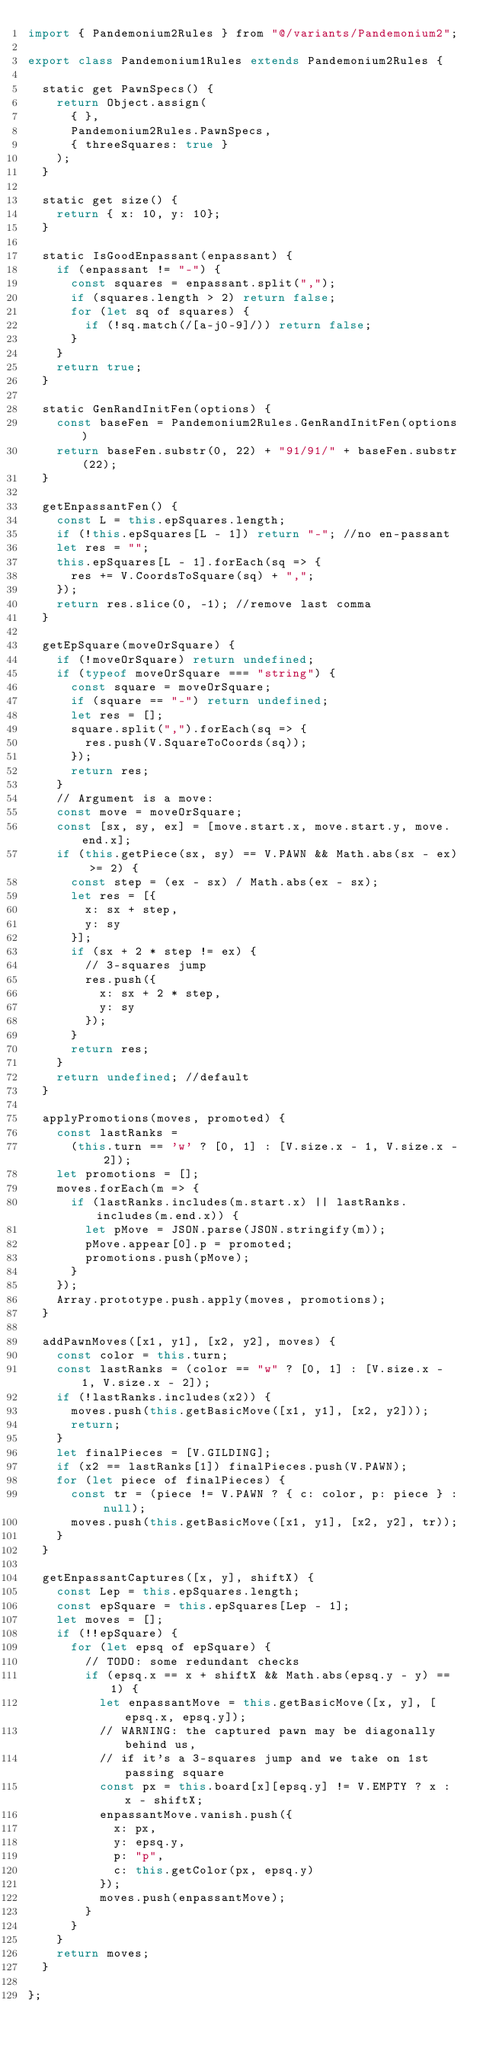Convert code to text. <code><loc_0><loc_0><loc_500><loc_500><_JavaScript_>import { Pandemonium2Rules } from "@/variants/Pandemonium2";

export class Pandemonium1Rules extends Pandemonium2Rules {

  static get PawnSpecs() {
    return Object.assign(
      { },
      Pandemonium2Rules.PawnSpecs,
      { threeSquares: true }
    );
  }

  static get size() {
    return { x: 10, y: 10};
  }

  static IsGoodEnpassant(enpassant) {
    if (enpassant != "-") {
      const squares = enpassant.split(",");
      if (squares.length > 2) return false;
      for (let sq of squares) {
        if (!sq.match(/[a-j0-9]/)) return false;
      }
    }
    return true;
  }

  static GenRandInitFen(options) {
    const baseFen = Pandemonium2Rules.GenRandInitFen(options)
    return baseFen.substr(0, 22) + "91/91/" + baseFen.substr(22);
  }

  getEnpassantFen() {
    const L = this.epSquares.length;
    if (!this.epSquares[L - 1]) return "-"; //no en-passant
    let res = "";
    this.epSquares[L - 1].forEach(sq => {
      res += V.CoordsToSquare(sq) + ",";
    });
    return res.slice(0, -1); //remove last comma
  }

  getEpSquare(moveOrSquare) {
    if (!moveOrSquare) return undefined;
    if (typeof moveOrSquare === "string") {
      const square = moveOrSquare;
      if (square == "-") return undefined;
      let res = [];
      square.split(",").forEach(sq => {
        res.push(V.SquareToCoords(sq));
      });
      return res;
    }
    // Argument is a move:
    const move = moveOrSquare;
    const [sx, sy, ex] = [move.start.x, move.start.y, move.end.x];
    if (this.getPiece(sx, sy) == V.PAWN && Math.abs(sx - ex) >= 2) {
      const step = (ex - sx) / Math.abs(ex - sx);
      let res = [{
        x: sx + step,
        y: sy
      }];
      if (sx + 2 * step != ex) {
        // 3-squares jump
        res.push({
          x: sx + 2 * step,
          y: sy
        });
      }
      return res;
    }
    return undefined; //default
  }

  applyPromotions(moves, promoted) {
    const lastRanks =
      (this.turn == 'w' ? [0, 1] : [V.size.x - 1, V.size.x - 2]);
    let promotions = [];
    moves.forEach(m => {
      if (lastRanks.includes(m.start.x) || lastRanks.includes(m.end.x)) {
        let pMove = JSON.parse(JSON.stringify(m));
        pMove.appear[0].p = promoted;
        promotions.push(pMove);
      }
    });
    Array.prototype.push.apply(moves, promotions);
  }

  addPawnMoves([x1, y1], [x2, y2], moves) {
    const color = this.turn;
    const lastRanks = (color == "w" ? [0, 1] : [V.size.x - 1, V.size.x - 2]);
    if (!lastRanks.includes(x2)) {
      moves.push(this.getBasicMove([x1, y1], [x2, y2]));
      return;
    }
    let finalPieces = [V.GILDING];
    if (x2 == lastRanks[1]) finalPieces.push(V.PAWN);
    for (let piece of finalPieces) {
      const tr = (piece != V.PAWN ? { c: color, p: piece } : null);
      moves.push(this.getBasicMove([x1, y1], [x2, y2], tr));
    }
  }

  getEnpassantCaptures([x, y], shiftX) {
    const Lep = this.epSquares.length;
    const epSquare = this.epSquares[Lep - 1];
    let moves = [];
    if (!!epSquare) {
      for (let epsq of epSquare) {
        // TODO: some redundant checks
        if (epsq.x == x + shiftX && Math.abs(epsq.y - y) == 1) {
          let enpassantMove = this.getBasicMove([x, y], [epsq.x, epsq.y]);
          // WARNING: the captured pawn may be diagonally behind us,
          // if it's a 3-squares jump and we take on 1st passing square
          const px = this.board[x][epsq.y] != V.EMPTY ? x : x - shiftX;
          enpassantMove.vanish.push({
            x: px,
            y: epsq.y,
            p: "p",
            c: this.getColor(px, epsq.y)
          });
          moves.push(enpassantMove);
        }
      }
    }
    return moves;
  }

};
</code> 